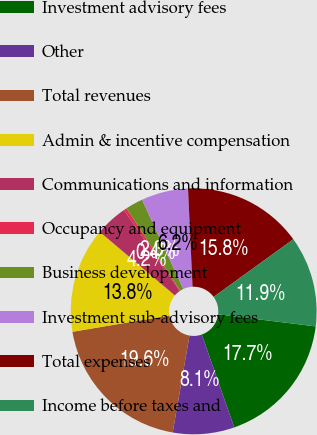Convert chart to OTSL. <chart><loc_0><loc_0><loc_500><loc_500><pie_chart><fcel>Investment advisory fees<fcel>Other<fcel>Total revenues<fcel>Admin & incentive compensation<fcel>Communications and information<fcel>Occupancy and equipment<fcel>Business development<fcel>Investment sub-advisory fees<fcel>Total expenses<fcel>Income before taxes and<nl><fcel>17.69%<fcel>8.08%<fcel>19.61%<fcel>13.84%<fcel>4.23%<fcel>0.39%<fcel>2.31%<fcel>6.16%<fcel>15.77%<fcel>11.92%<nl></chart> 